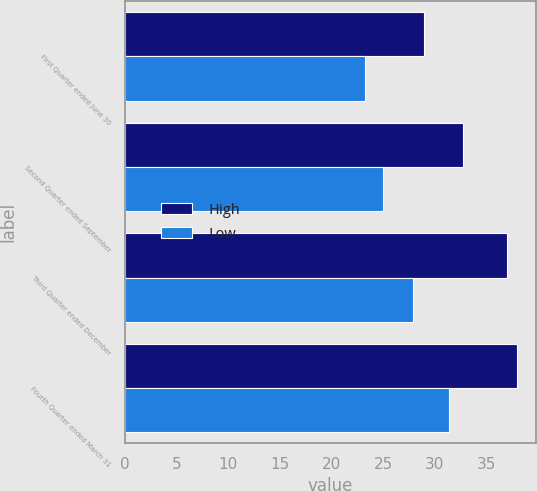Convert chart to OTSL. <chart><loc_0><loc_0><loc_500><loc_500><stacked_bar_chart><ecel><fcel>First Quarter ended June 30<fcel>Second Quarter ended September<fcel>Third Quarter ended December<fcel>Fourth Quarter ended March 31<nl><fcel>High<fcel>28.98<fcel>32.71<fcel>37<fcel>37.95<nl><fcel>Low<fcel>23.3<fcel>25.01<fcel>27.89<fcel>31.36<nl></chart> 